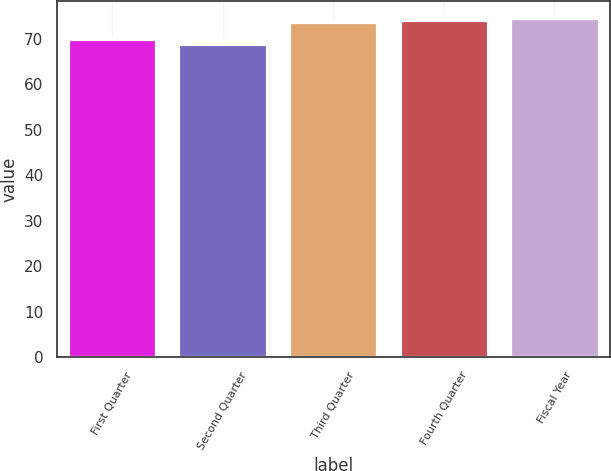<chart> <loc_0><loc_0><loc_500><loc_500><bar_chart><fcel>First Quarter<fcel>Second Quarter<fcel>Third Quarter<fcel>Fourth Quarter<fcel>Fiscal Year<nl><fcel>69.92<fcel>68.92<fcel>73.57<fcel>74.05<fcel>74.53<nl></chart> 